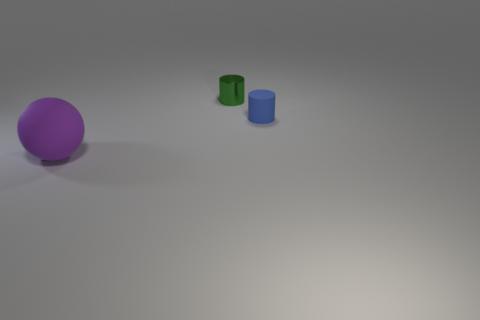Add 2 rubber objects. How many objects exist? 5 Subtract all cylinders. How many objects are left? 1 Add 1 purple matte things. How many purple matte things are left? 2 Add 2 tiny brown matte balls. How many tiny brown matte balls exist? 2 Subtract 0 purple blocks. How many objects are left? 3 Subtract all large blue blocks. Subtract all large purple spheres. How many objects are left? 2 